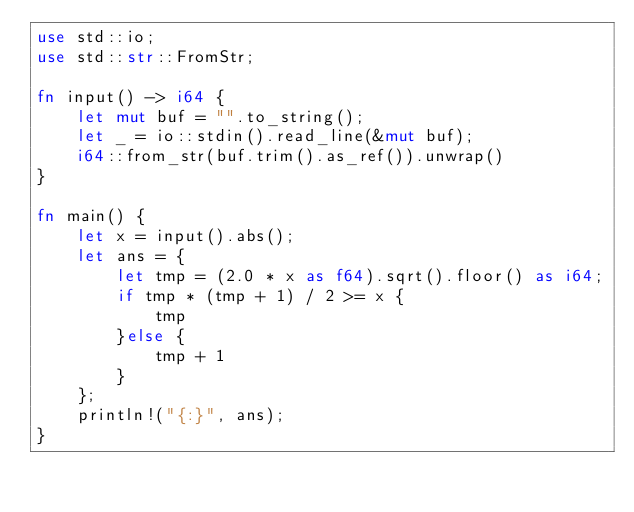<code> <loc_0><loc_0><loc_500><loc_500><_Rust_>use std::io;
use std::str::FromStr;

fn input() -> i64 {
    let mut buf = "".to_string();
    let _ = io::stdin().read_line(&mut buf);
    i64::from_str(buf.trim().as_ref()).unwrap()
}

fn main() {
    let x = input().abs();
    let ans = {
        let tmp = (2.0 * x as f64).sqrt().floor() as i64;
        if tmp * (tmp + 1) / 2 >= x {
            tmp
        }else {
            tmp + 1
        }
    };
    println!("{:}", ans);
}
</code> 